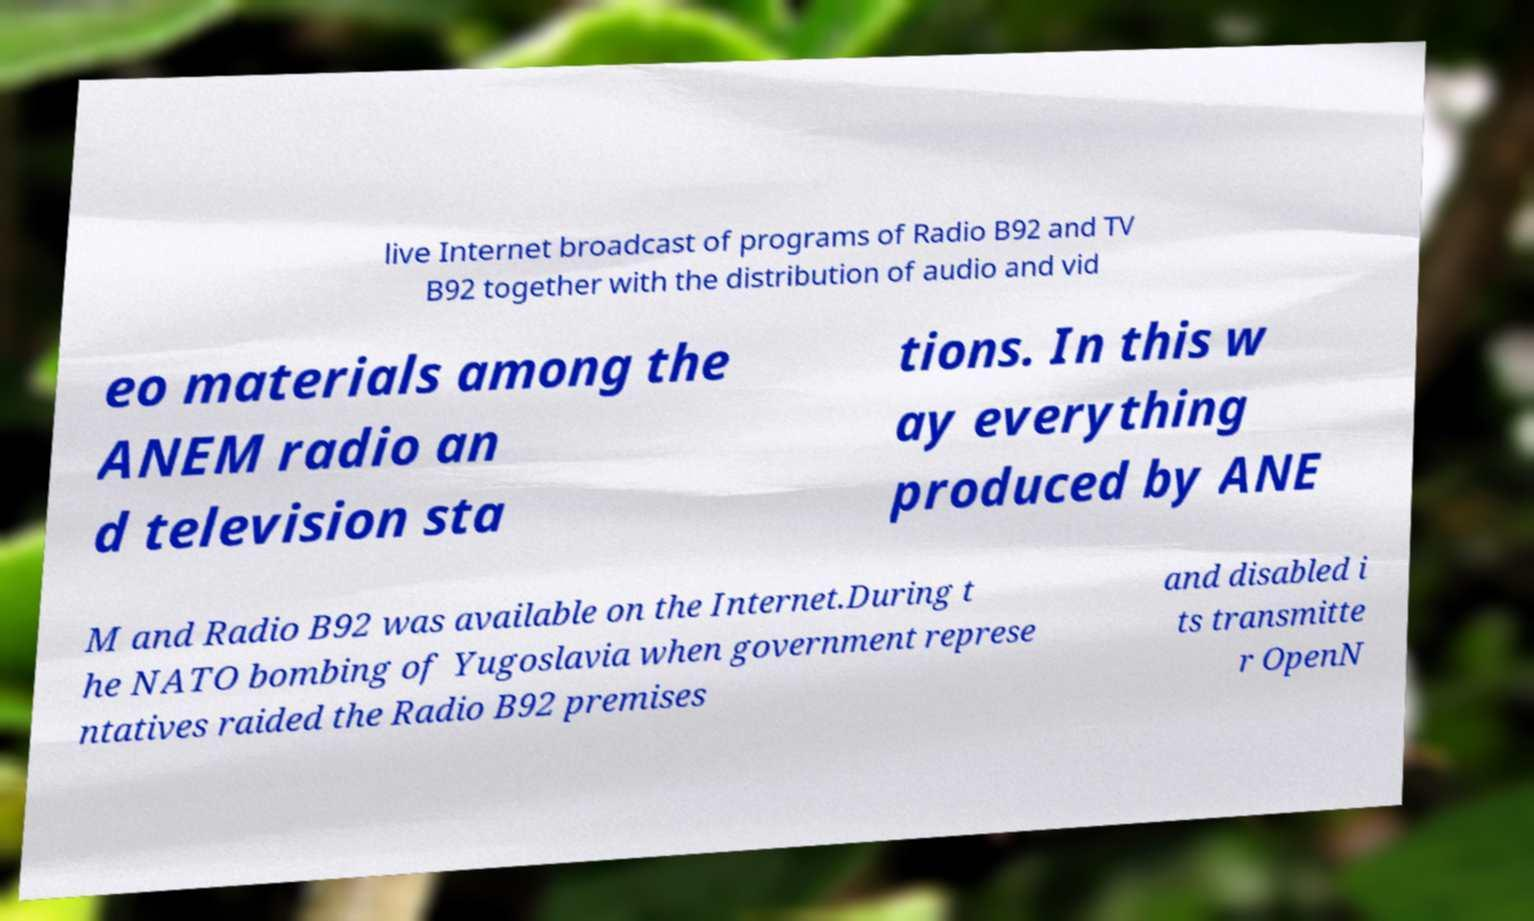Can you accurately transcribe the text from the provided image for me? live Internet broadcast of programs of Radio B92 and TV B92 together with the distribution of audio and vid eo materials among the ANEM radio an d television sta tions. In this w ay everything produced by ANE M and Radio B92 was available on the Internet.During t he NATO bombing of Yugoslavia when government represe ntatives raided the Radio B92 premises and disabled i ts transmitte r OpenN 